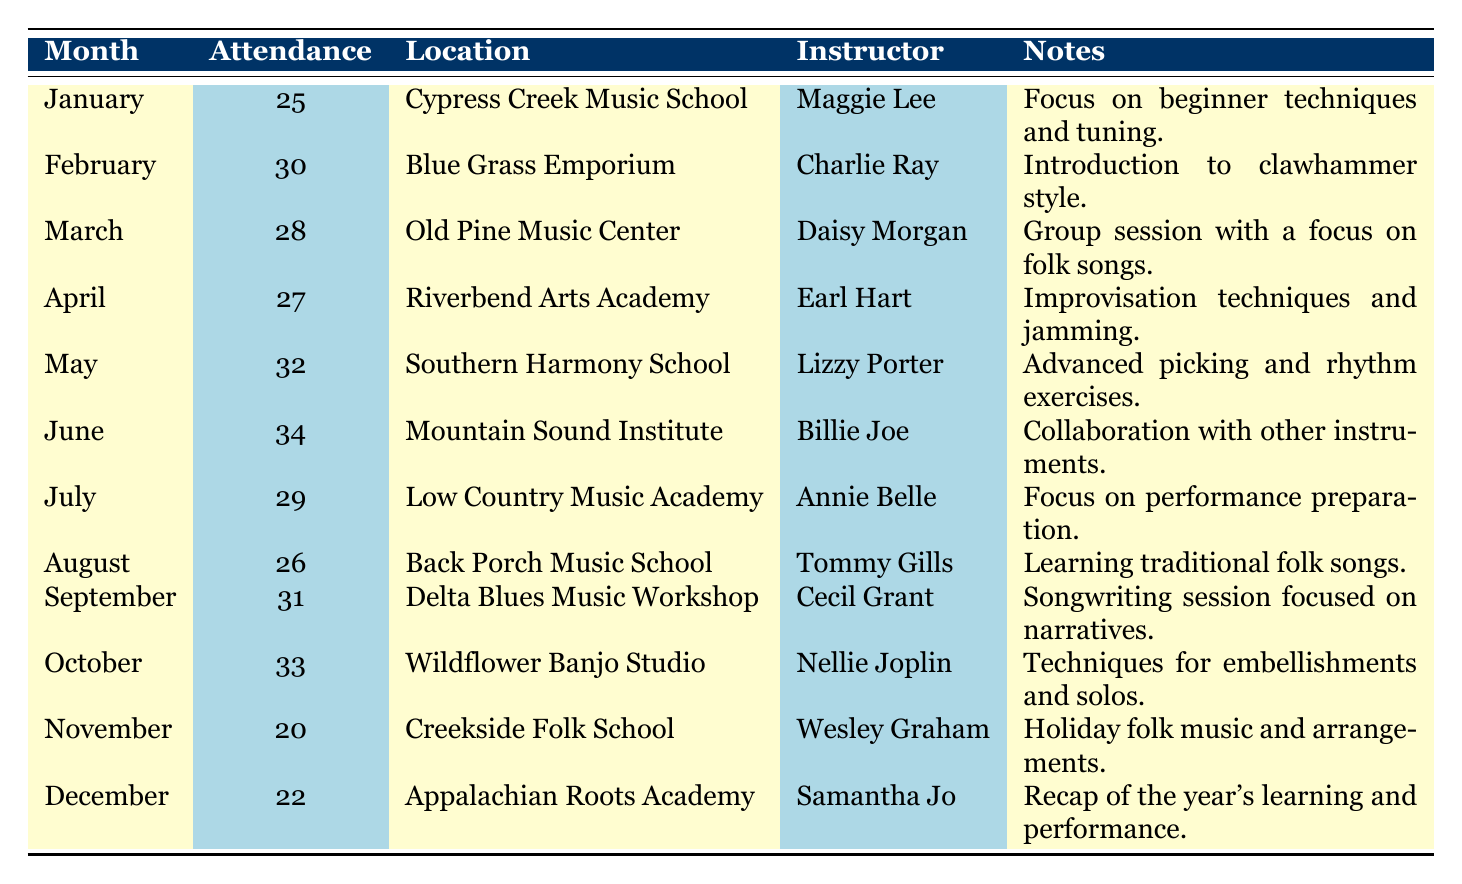What was the highest attendance for a weekly banjo lesson? The highest attendance recorded is 34 in June at the Mountain Sound Institute, as seen in the attendance column of the table.
Answer: 34 Which instructor taught the lesson in March? According to the table, the instructor for March was Daisy Morgan, as listed under the instructor column for that month.
Answer: Daisy Morgan What is the total attendance for the first half of the year (January to June)? The total attendance for the first half of the year is calculated by adding attendance values from January to June: 25 + 30 + 28 + 27 + 32 + 34 = 176.
Answer: 176 Was there a month when the attendance fell below 25? According to the table, all months had an attendance count above 20, with the lowest being 20 in November, so there were no months with attendance below 25.
Answer: No How many lessons had an attendance of 30 or greater? By reviewing the attendance values in the table, we see that lessons in February, May, June, September, and October had attendances of 30 or greater (30, 32, 34, 31, 33), totaling 5 months.
Answer: 5 In which month did the lesson focus on improvisation techniques? Referring to the notes column, the lesson focusing on improvisation techniques was held in April at the Riverbend Arts Academy.
Answer: April What was the average attendance from July to December? The total attendance from July to December is 29 + 26 + 31 + 33 + 20 + 22 = 161. There are 6 months in this range, so the average attendance is 161 / 6 = 26.833, which is approximately 27 when rounded.
Answer: 27 Which location offered lessons focused on learning traditional folk songs? The lesson focused on learning traditional folk songs was held at the Back Porch Music School in August, as stated in the location and notes columns.
Answer: Back Porch Music School How many instructors had attendance less than 25 for their sessions? From the data, only one instructor, Wesley Graham in November, had attendance of 20, which is less than 25. The other months have attendance above that threshold.
Answer: 1 